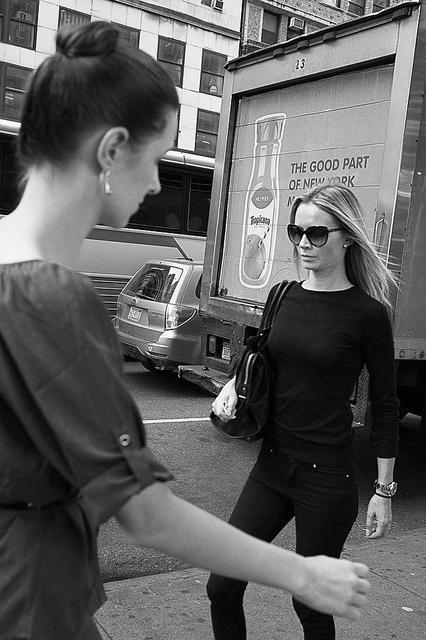How many women are wearing sunglasses?
Give a very brief answer. 1. How many people can be seen?
Give a very brief answer. 2. 